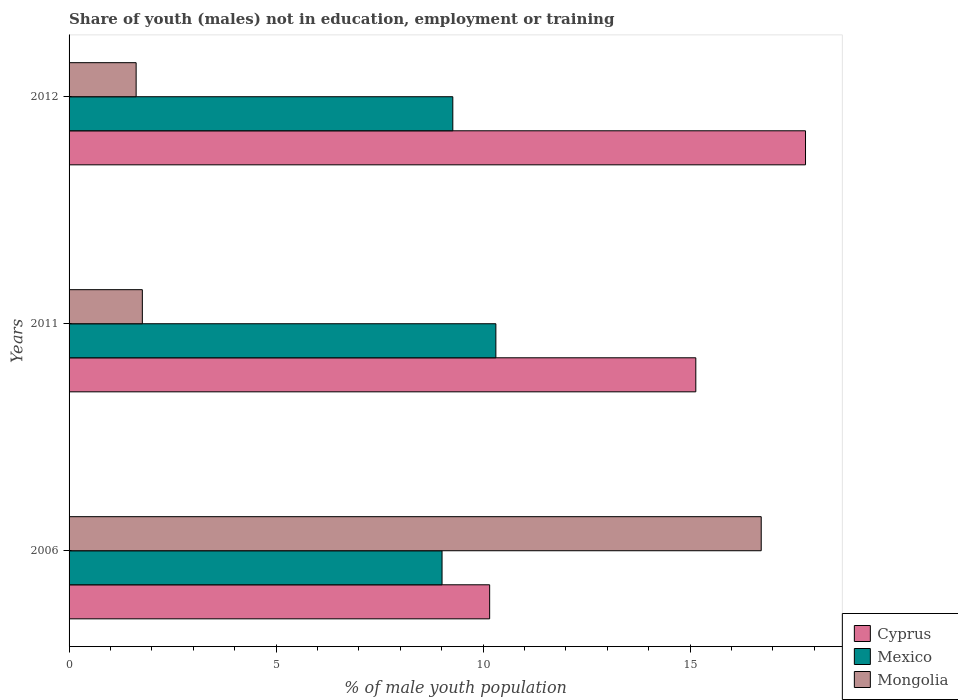How many different coloured bars are there?
Provide a short and direct response. 3. Are the number of bars per tick equal to the number of legend labels?
Keep it short and to the point. Yes. How many bars are there on the 1st tick from the top?
Give a very brief answer. 3. In how many cases, is the number of bars for a given year not equal to the number of legend labels?
Provide a succinct answer. 0. What is the percentage of unemployed males population in in Cyprus in 2006?
Keep it short and to the point. 10.16. Across all years, what is the maximum percentage of unemployed males population in in Cyprus?
Your response must be concise. 17.79. Across all years, what is the minimum percentage of unemployed males population in in Mongolia?
Offer a very short reply. 1.62. In which year was the percentage of unemployed males population in in Cyprus minimum?
Offer a very short reply. 2006. What is the total percentage of unemployed males population in in Mexico in the graph?
Keep it short and to the point. 28.59. What is the difference between the percentage of unemployed males population in in Mongolia in 2006 and that in 2012?
Offer a very short reply. 15.1. What is the difference between the percentage of unemployed males population in in Mongolia in 2006 and the percentage of unemployed males population in in Cyprus in 2011?
Offer a terse response. 1.58. What is the average percentage of unemployed males population in in Mongolia per year?
Your answer should be compact. 6.7. In the year 2006, what is the difference between the percentage of unemployed males population in in Mongolia and percentage of unemployed males population in in Cyprus?
Offer a very short reply. 6.56. In how many years, is the percentage of unemployed males population in in Mexico greater than 5 %?
Offer a very short reply. 3. What is the ratio of the percentage of unemployed males population in in Mexico in 2006 to that in 2012?
Provide a short and direct response. 0.97. Is the difference between the percentage of unemployed males population in in Mongolia in 2006 and 2011 greater than the difference between the percentage of unemployed males population in in Cyprus in 2006 and 2011?
Give a very brief answer. Yes. What is the difference between the highest and the second highest percentage of unemployed males population in in Mexico?
Make the answer very short. 1.04. What is the difference between the highest and the lowest percentage of unemployed males population in in Cyprus?
Ensure brevity in your answer.  7.63. Is the sum of the percentage of unemployed males population in in Cyprus in 2011 and 2012 greater than the maximum percentage of unemployed males population in in Mongolia across all years?
Ensure brevity in your answer.  Yes. What does the 1st bar from the top in 2006 represents?
Keep it short and to the point. Mongolia. What does the 1st bar from the bottom in 2012 represents?
Your answer should be compact. Cyprus. Is it the case that in every year, the sum of the percentage of unemployed males population in in Cyprus and percentage of unemployed males population in in Mexico is greater than the percentage of unemployed males population in in Mongolia?
Provide a succinct answer. Yes. How many bars are there?
Offer a very short reply. 9. How many years are there in the graph?
Ensure brevity in your answer.  3. Are the values on the major ticks of X-axis written in scientific E-notation?
Offer a terse response. No. Does the graph contain any zero values?
Your answer should be very brief. No. How many legend labels are there?
Your answer should be very brief. 3. What is the title of the graph?
Your response must be concise. Share of youth (males) not in education, employment or training. What is the label or title of the X-axis?
Offer a terse response. % of male youth population. What is the label or title of the Y-axis?
Make the answer very short. Years. What is the % of male youth population in Cyprus in 2006?
Your answer should be compact. 10.16. What is the % of male youth population in Mexico in 2006?
Keep it short and to the point. 9.01. What is the % of male youth population of Mongolia in 2006?
Ensure brevity in your answer.  16.72. What is the % of male youth population in Cyprus in 2011?
Offer a terse response. 15.14. What is the % of male youth population in Mexico in 2011?
Your answer should be compact. 10.31. What is the % of male youth population in Mongolia in 2011?
Ensure brevity in your answer.  1.77. What is the % of male youth population in Cyprus in 2012?
Keep it short and to the point. 17.79. What is the % of male youth population in Mexico in 2012?
Offer a very short reply. 9.27. What is the % of male youth population in Mongolia in 2012?
Keep it short and to the point. 1.62. Across all years, what is the maximum % of male youth population in Cyprus?
Give a very brief answer. 17.79. Across all years, what is the maximum % of male youth population of Mexico?
Offer a terse response. 10.31. Across all years, what is the maximum % of male youth population in Mongolia?
Ensure brevity in your answer.  16.72. Across all years, what is the minimum % of male youth population of Cyprus?
Offer a very short reply. 10.16. Across all years, what is the minimum % of male youth population in Mexico?
Your answer should be compact. 9.01. Across all years, what is the minimum % of male youth population in Mongolia?
Give a very brief answer. 1.62. What is the total % of male youth population of Cyprus in the graph?
Make the answer very short. 43.09. What is the total % of male youth population of Mexico in the graph?
Keep it short and to the point. 28.59. What is the total % of male youth population of Mongolia in the graph?
Make the answer very short. 20.11. What is the difference between the % of male youth population of Cyprus in 2006 and that in 2011?
Your answer should be compact. -4.98. What is the difference between the % of male youth population in Mexico in 2006 and that in 2011?
Give a very brief answer. -1.3. What is the difference between the % of male youth population of Mongolia in 2006 and that in 2011?
Provide a succinct answer. 14.95. What is the difference between the % of male youth population in Cyprus in 2006 and that in 2012?
Your answer should be compact. -7.63. What is the difference between the % of male youth population in Mexico in 2006 and that in 2012?
Keep it short and to the point. -0.26. What is the difference between the % of male youth population of Mongolia in 2006 and that in 2012?
Make the answer very short. 15.1. What is the difference between the % of male youth population in Cyprus in 2011 and that in 2012?
Your answer should be very brief. -2.65. What is the difference between the % of male youth population of Cyprus in 2006 and the % of male youth population of Mongolia in 2011?
Your answer should be very brief. 8.39. What is the difference between the % of male youth population of Mexico in 2006 and the % of male youth population of Mongolia in 2011?
Provide a succinct answer. 7.24. What is the difference between the % of male youth population of Cyprus in 2006 and the % of male youth population of Mexico in 2012?
Keep it short and to the point. 0.89. What is the difference between the % of male youth population in Cyprus in 2006 and the % of male youth population in Mongolia in 2012?
Give a very brief answer. 8.54. What is the difference between the % of male youth population in Mexico in 2006 and the % of male youth population in Mongolia in 2012?
Make the answer very short. 7.39. What is the difference between the % of male youth population in Cyprus in 2011 and the % of male youth population in Mexico in 2012?
Offer a terse response. 5.87. What is the difference between the % of male youth population of Cyprus in 2011 and the % of male youth population of Mongolia in 2012?
Offer a terse response. 13.52. What is the difference between the % of male youth population of Mexico in 2011 and the % of male youth population of Mongolia in 2012?
Your response must be concise. 8.69. What is the average % of male youth population in Cyprus per year?
Offer a terse response. 14.36. What is the average % of male youth population in Mexico per year?
Your response must be concise. 9.53. What is the average % of male youth population in Mongolia per year?
Give a very brief answer. 6.7. In the year 2006, what is the difference between the % of male youth population in Cyprus and % of male youth population in Mexico?
Offer a terse response. 1.15. In the year 2006, what is the difference between the % of male youth population of Cyprus and % of male youth population of Mongolia?
Make the answer very short. -6.56. In the year 2006, what is the difference between the % of male youth population in Mexico and % of male youth population in Mongolia?
Make the answer very short. -7.71. In the year 2011, what is the difference between the % of male youth population of Cyprus and % of male youth population of Mexico?
Keep it short and to the point. 4.83. In the year 2011, what is the difference between the % of male youth population of Cyprus and % of male youth population of Mongolia?
Provide a short and direct response. 13.37. In the year 2011, what is the difference between the % of male youth population of Mexico and % of male youth population of Mongolia?
Ensure brevity in your answer.  8.54. In the year 2012, what is the difference between the % of male youth population of Cyprus and % of male youth population of Mexico?
Offer a very short reply. 8.52. In the year 2012, what is the difference between the % of male youth population of Cyprus and % of male youth population of Mongolia?
Make the answer very short. 16.17. In the year 2012, what is the difference between the % of male youth population of Mexico and % of male youth population of Mongolia?
Your answer should be compact. 7.65. What is the ratio of the % of male youth population of Cyprus in 2006 to that in 2011?
Make the answer very short. 0.67. What is the ratio of the % of male youth population in Mexico in 2006 to that in 2011?
Keep it short and to the point. 0.87. What is the ratio of the % of male youth population of Mongolia in 2006 to that in 2011?
Make the answer very short. 9.45. What is the ratio of the % of male youth population of Cyprus in 2006 to that in 2012?
Keep it short and to the point. 0.57. What is the ratio of the % of male youth population in Mexico in 2006 to that in 2012?
Give a very brief answer. 0.97. What is the ratio of the % of male youth population in Mongolia in 2006 to that in 2012?
Give a very brief answer. 10.32. What is the ratio of the % of male youth population of Cyprus in 2011 to that in 2012?
Provide a succinct answer. 0.85. What is the ratio of the % of male youth population of Mexico in 2011 to that in 2012?
Your answer should be compact. 1.11. What is the ratio of the % of male youth population of Mongolia in 2011 to that in 2012?
Your answer should be compact. 1.09. What is the difference between the highest and the second highest % of male youth population of Cyprus?
Your response must be concise. 2.65. What is the difference between the highest and the second highest % of male youth population in Mongolia?
Make the answer very short. 14.95. What is the difference between the highest and the lowest % of male youth population in Cyprus?
Your answer should be compact. 7.63. What is the difference between the highest and the lowest % of male youth population in Mexico?
Offer a very short reply. 1.3. 